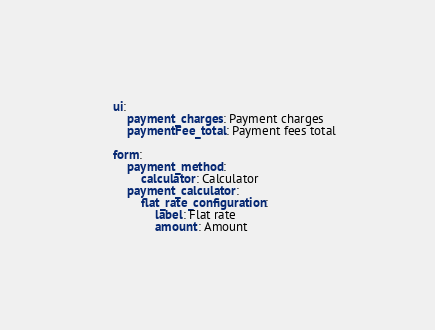Convert code to text. <code><loc_0><loc_0><loc_500><loc_500><_YAML_>
    ui:
        payment_charges: Payment charges
        paymentFee_total: Payment fees total

    form:
        payment_method:
            calculator: Calculator
        payment_calculator:
            flat_rate_configuration:
                label: Flat rate
                amount: Amount
</code> 